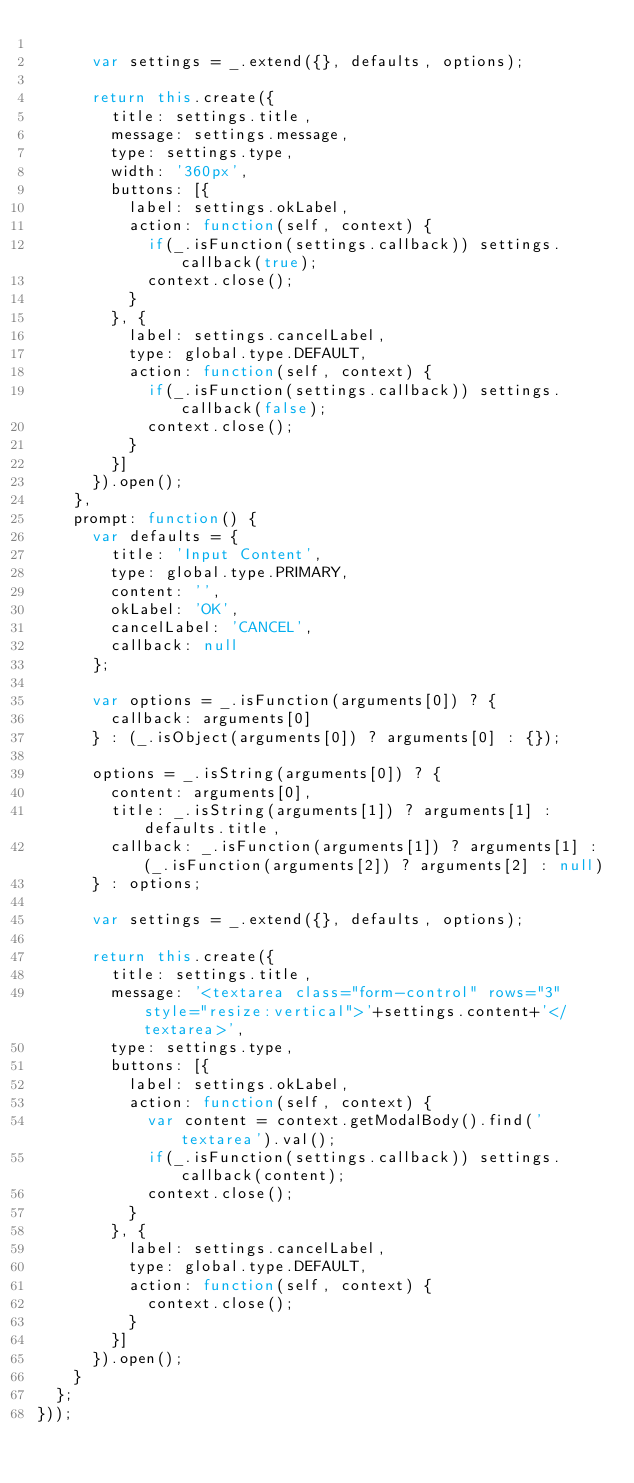<code> <loc_0><loc_0><loc_500><loc_500><_JavaScript_>
      var settings = _.extend({}, defaults, options);

      return this.create({
        title: settings.title,
        message: settings.message,
        type: settings.type,
        width: '360px',
        buttons: [{
          label: settings.okLabel,
          action: function(self, context) {
            if(_.isFunction(settings.callback)) settings.callback(true);
            context.close();
          }
        }, {
          label: settings.cancelLabel,
          type: global.type.DEFAULT,
          action: function(self, context) {
            if(_.isFunction(settings.callback)) settings.callback(false);
            context.close();
          }
        }]
      }).open();
    },
    prompt: function() {
      var defaults = {
        title: 'Input Content',
        type: global.type.PRIMARY,
        content: '',
        okLabel: 'OK',
        cancelLabel: 'CANCEL',
        callback: null
      };

      var options = _.isFunction(arguments[0]) ? {
        callback: arguments[0]
      } : (_.isObject(arguments[0]) ? arguments[0] : {});

      options = _.isString(arguments[0]) ? {
        content: arguments[0],
        title: _.isString(arguments[1]) ? arguments[1] : defaults.title,
        callback: _.isFunction(arguments[1]) ? arguments[1] : (_.isFunction(arguments[2]) ? arguments[2] : null)
      } : options;

      var settings = _.extend({}, defaults, options);

      return this.create({
        title: settings.title,
        message: '<textarea class="form-control" rows="3" style="resize:vertical">'+settings.content+'</textarea>',
        type: settings.type,
        buttons: [{
          label: settings.okLabel,
          action: function(self, context) {
            var content = context.getModalBody().find('textarea').val();
            if(_.isFunction(settings.callback)) settings.callback(content);
            context.close();
          }
        }, {
          label: settings.cancelLabel,
          type: global.type.DEFAULT,
          action: function(self, context) {
            context.close();
          }
        }]
      }).open();
    }
  };
}));</code> 